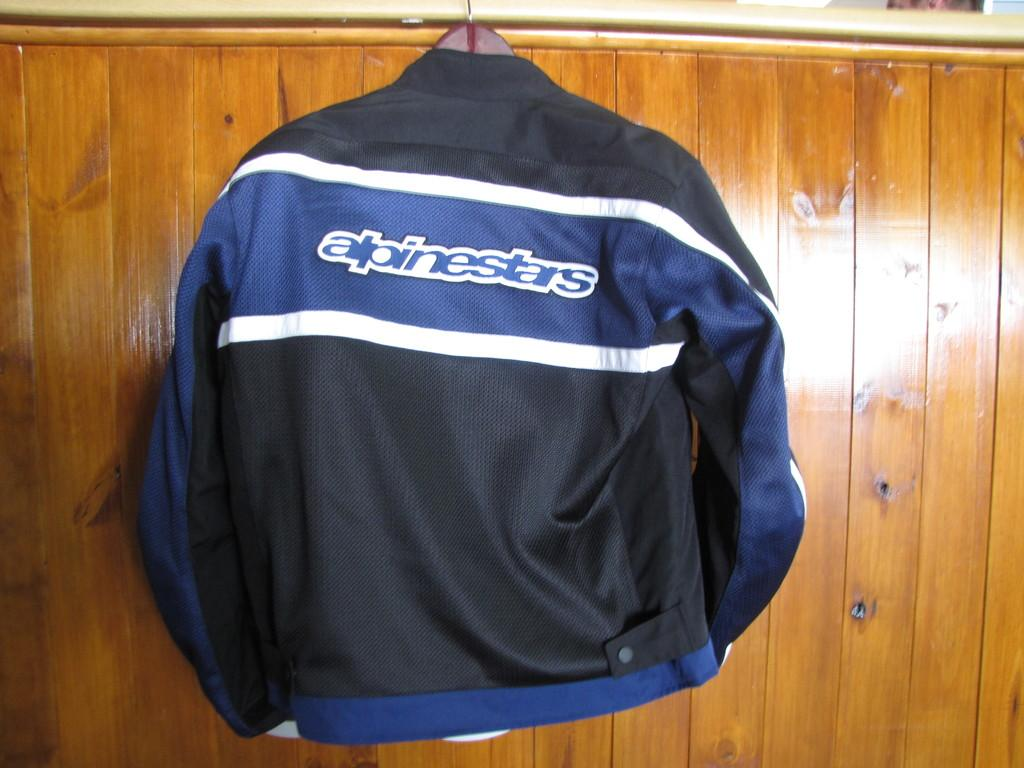<image>
Present a compact description of the photo's key features. an alpinestars jacket is hanging on the hanger 